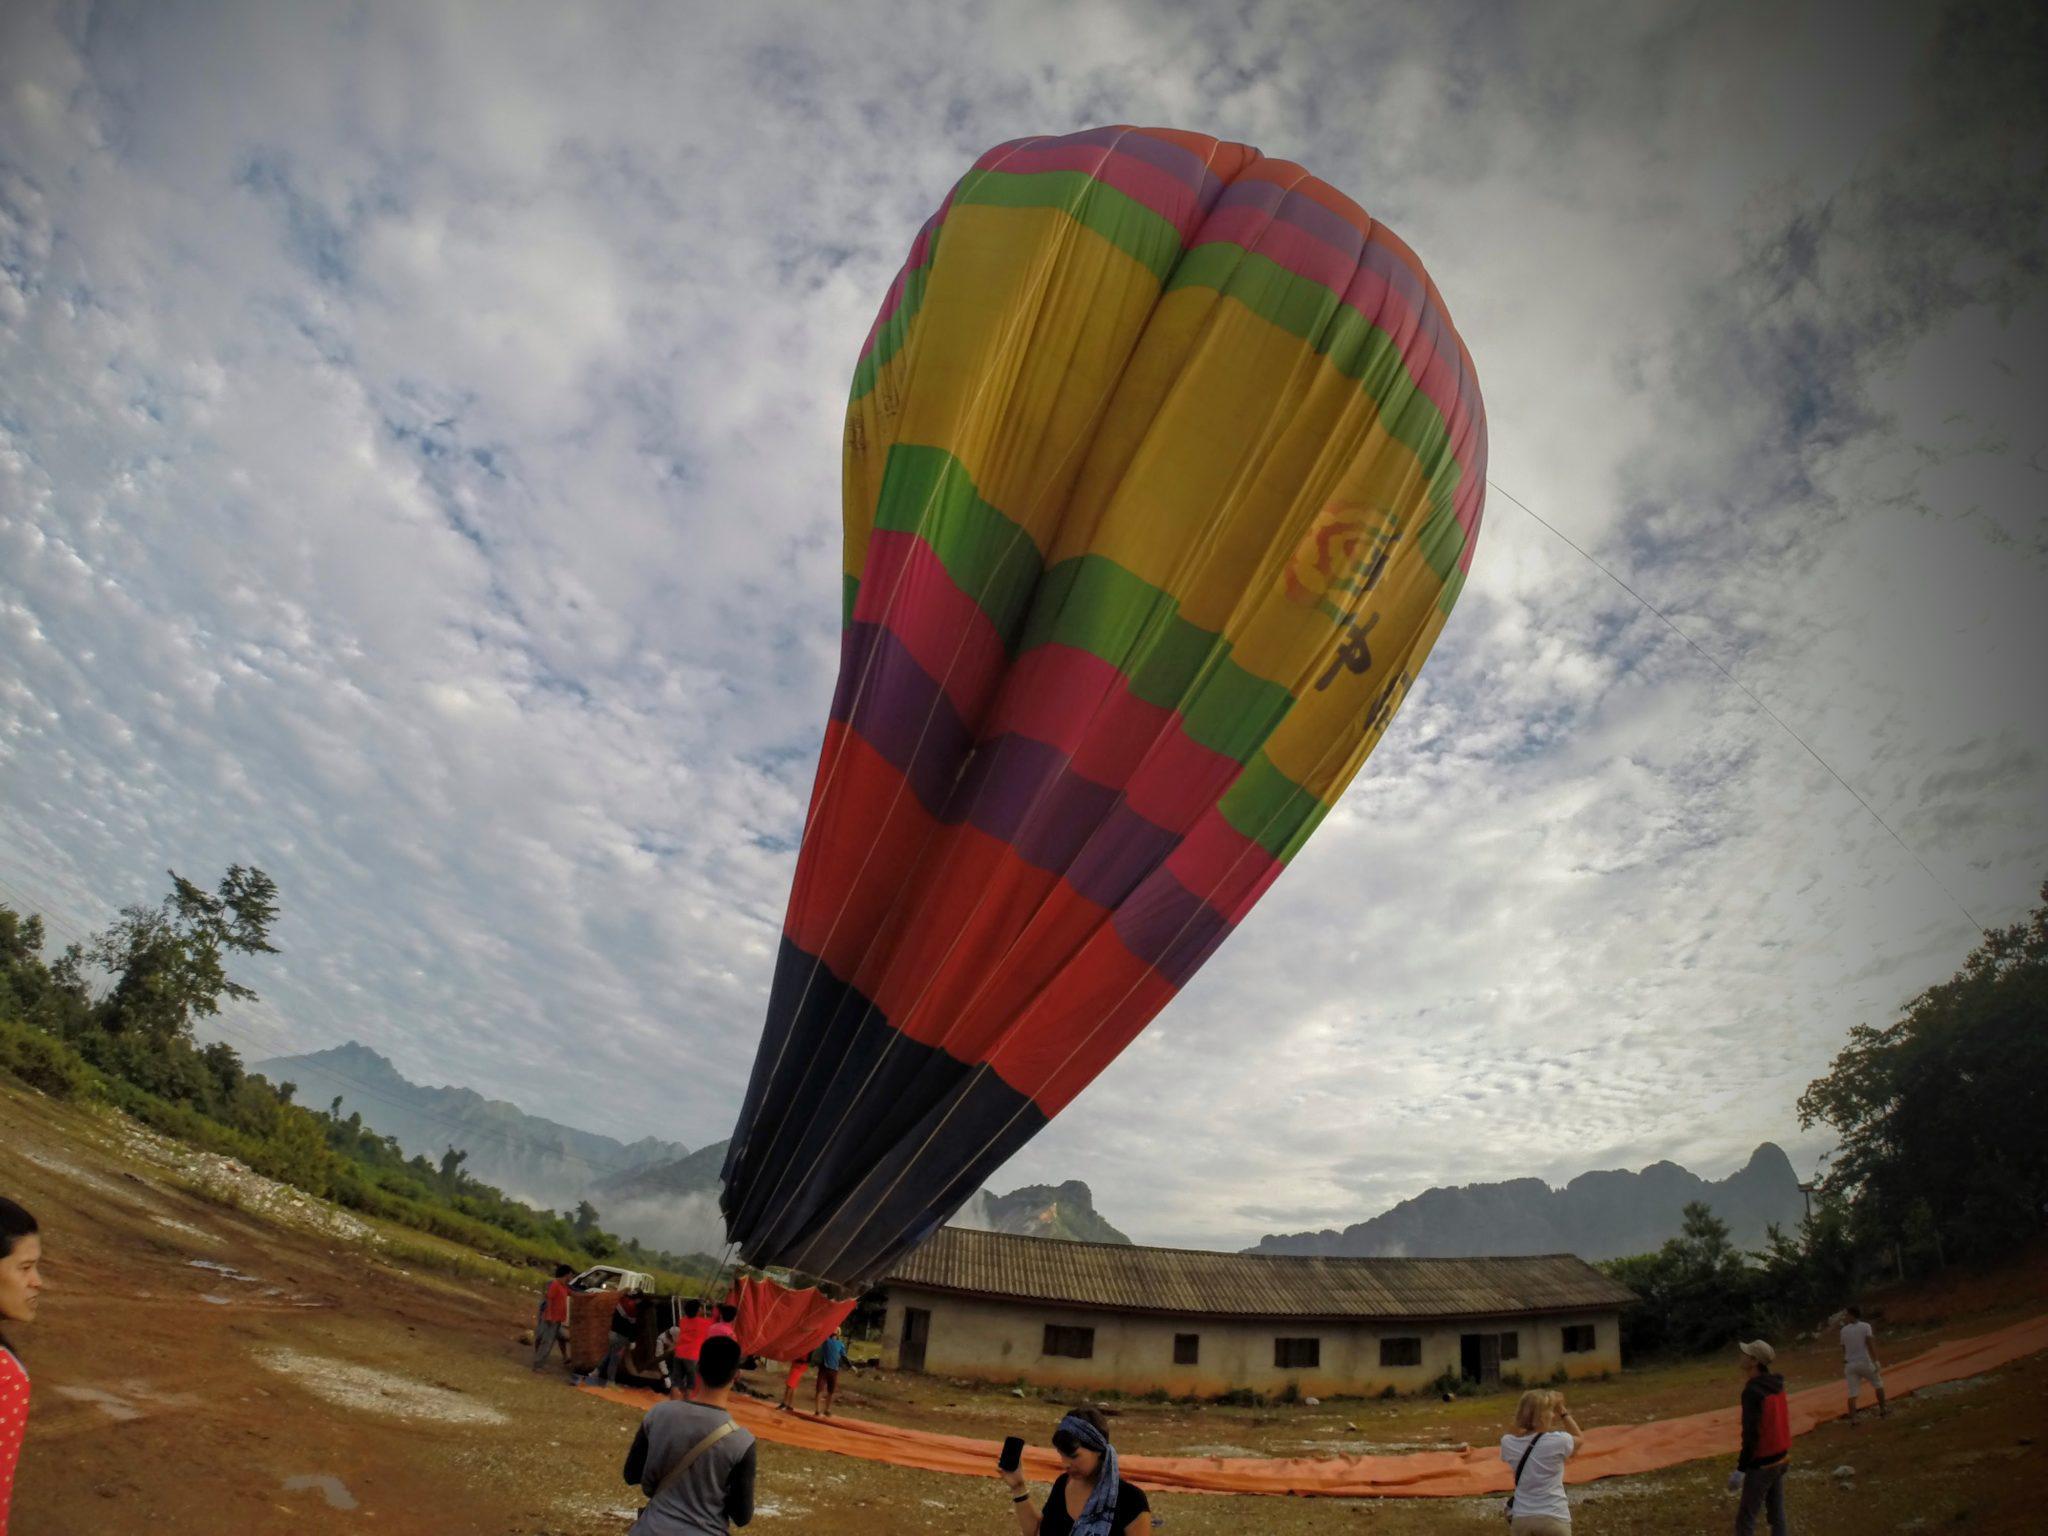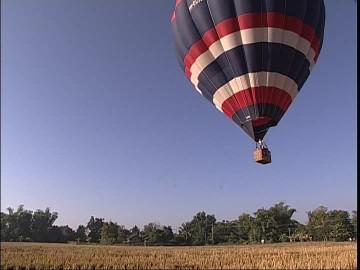The first image is the image on the left, the second image is the image on the right. For the images displayed, is the sentence "One image shows a red, white and blue balloon with stripes, and the other shows a multicolored striped balloon with at least six colors." factually correct? Answer yes or no. Yes. 